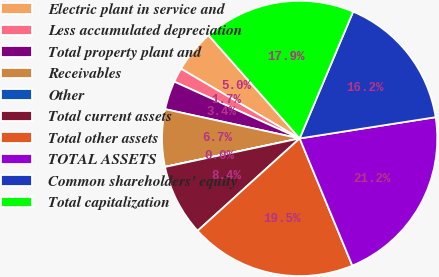Convert chart. <chart><loc_0><loc_0><loc_500><loc_500><pie_chart><fcel>Electric plant in service and<fcel>Less accumulated depreciation<fcel>Total property plant and<fcel>Receivables<fcel>Other<fcel>Total current assets<fcel>Total other assets<fcel>TOTAL ASSETS<fcel>Common shareholders' equity<fcel>Total capitalization<nl><fcel>5.04%<fcel>1.68%<fcel>3.36%<fcel>6.72%<fcel>0.01%<fcel>8.39%<fcel>19.54%<fcel>21.22%<fcel>16.18%<fcel>17.86%<nl></chart> 